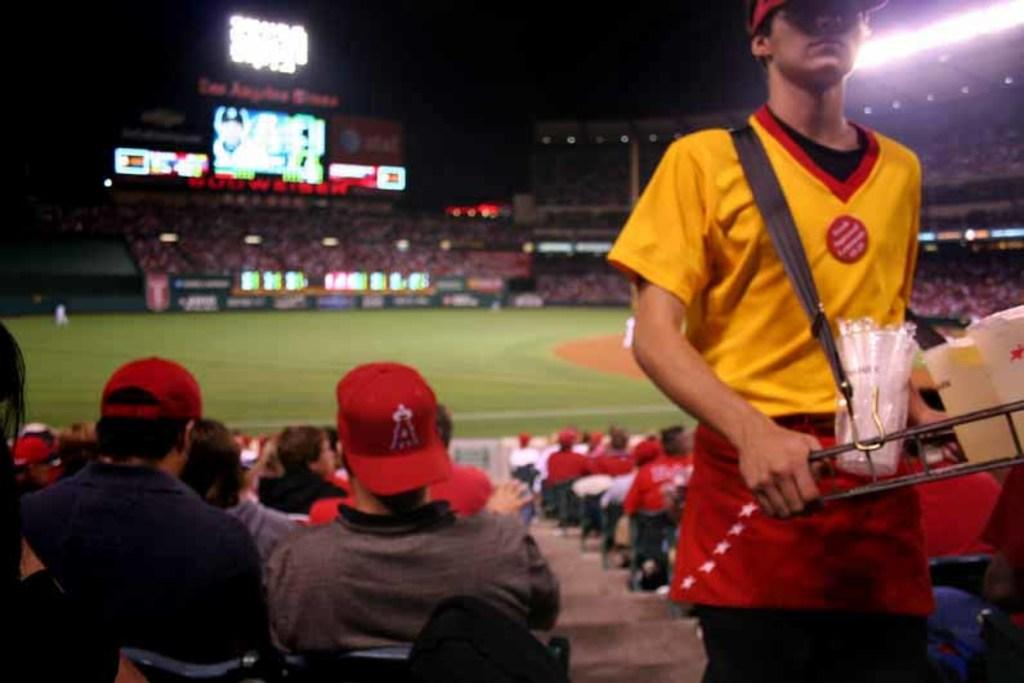Provide a one-sentence caption for the provided image. The backwards cap worn by a spectator at a ball game has a red letter A on it. 